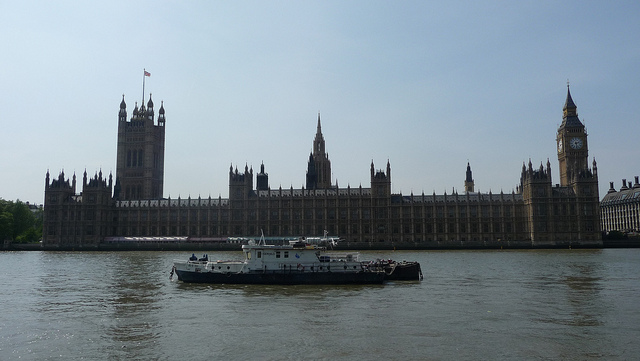<image>What river is this? I don't know what river this is. It might be the Thames, the Seine, or the Charles. What river is this? I don't know what river this is. It is possible that it is the Thames, Seine, or Charles river. 